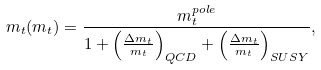<formula> <loc_0><loc_0><loc_500><loc_500>m _ { t } ( m _ { t } ) = \frac { m _ { t } ^ { p o l e } } { 1 + \left ( \frac { \Delta m _ { t } } { m _ { t } } \right ) _ { Q C D } + \left ( \frac { \Delta m _ { t } } { m _ { t } } \right ) _ { S U S Y } } ,</formula> 